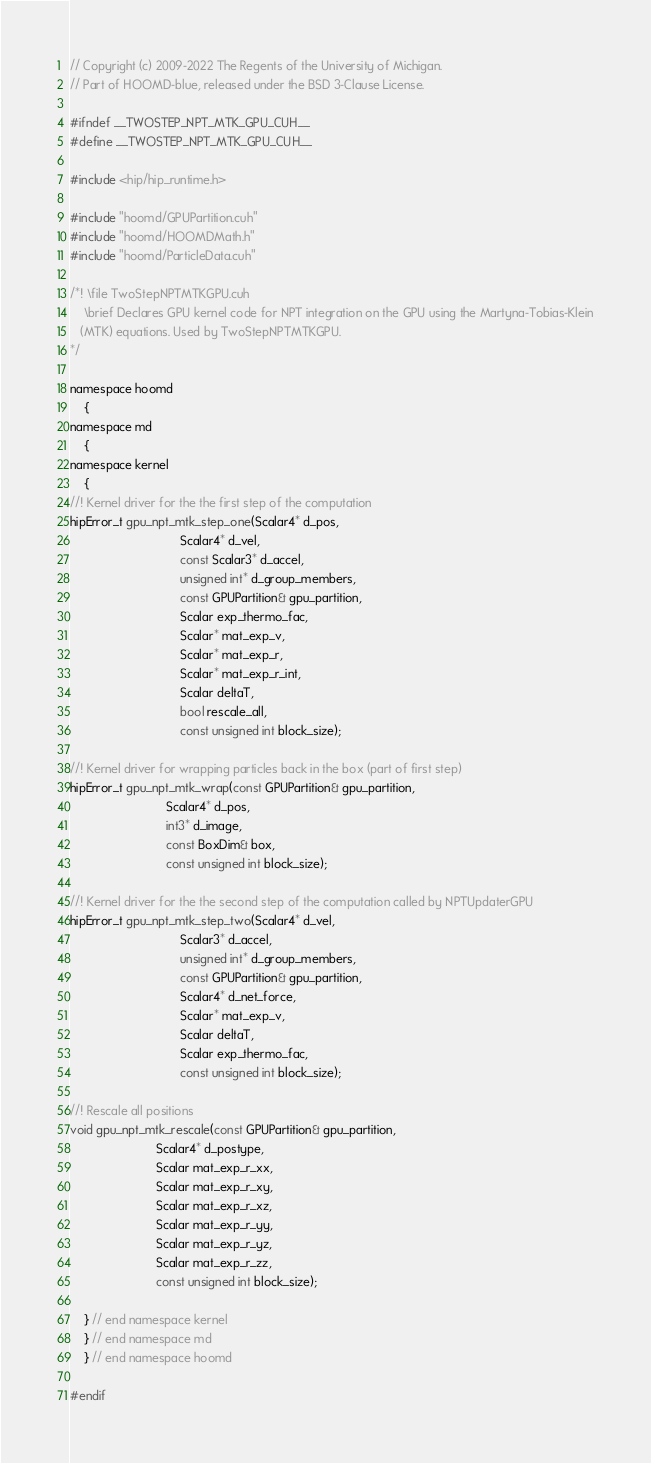<code> <loc_0><loc_0><loc_500><loc_500><_Cuda_>// Copyright (c) 2009-2022 The Regents of the University of Michigan.
// Part of HOOMD-blue, released under the BSD 3-Clause License.

#ifndef __TWOSTEP_NPT_MTK_GPU_CUH__
#define __TWOSTEP_NPT_MTK_GPU_CUH__

#include <hip/hip_runtime.h>

#include "hoomd/GPUPartition.cuh"
#include "hoomd/HOOMDMath.h"
#include "hoomd/ParticleData.cuh"

/*! \file TwoStepNPTMTKGPU.cuh
    \brief Declares GPU kernel code for NPT integration on the GPU using the Martyna-Tobias-Klein
   (MTK) equations. Used by TwoStepNPTMTKGPU.
*/

namespace hoomd
    {
namespace md
    {
namespace kernel
    {
//! Kernel driver for the the first step of the computation
hipError_t gpu_npt_mtk_step_one(Scalar4* d_pos,
                                Scalar4* d_vel,
                                const Scalar3* d_accel,
                                unsigned int* d_group_members,
                                const GPUPartition& gpu_partition,
                                Scalar exp_thermo_fac,
                                Scalar* mat_exp_v,
                                Scalar* mat_exp_r,
                                Scalar* mat_exp_r_int,
                                Scalar deltaT,
                                bool rescale_all,
                                const unsigned int block_size);

//! Kernel driver for wrapping particles back in the box (part of first step)
hipError_t gpu_npt_mtk_wrap(const GPUPartition& gpu_partition,
                            Scalar4* d_pos,
                            int3* d_image,
                            const BoxDim& box,
                            const unsigned int block_size);

//! Kernel driver for the the second step of the computation called by NPTUpdaterGPU
hipError_t gpu_npt_mtk_step_two(Scalar4* d_vel,
                                Scalar3* d_accel,
                                unsigned int* d_group_members,
                                const GPUPartition& gpu_partition,
                                Scalar4* d_net_force,
                                Scalar* mat_exp_v,
                                Scalar deltaT,
                                Scalar exp_thermo_fac,
                                const unsigned int block_size);

//! Rescale all positions
void gpu_npt_mtk_rescale(const GPUPartition& gpu_partition,
                         Scalar4* d_postype,
                         Scalar mat_exp_r_xx,
                         Scalar mat_exp_r_xy,
                         Scalar mat_exp_r_xz,
                         Scalar mat_exp_r_yy,
                         Scalar mat_exp_r_yz,
                         Scalar mat_exp_r_zz,
                         const unsigned int block_size);

    } // end namespace kernel
    } // end namespace md
    } // end namespace hoomd

#endif
</code> 